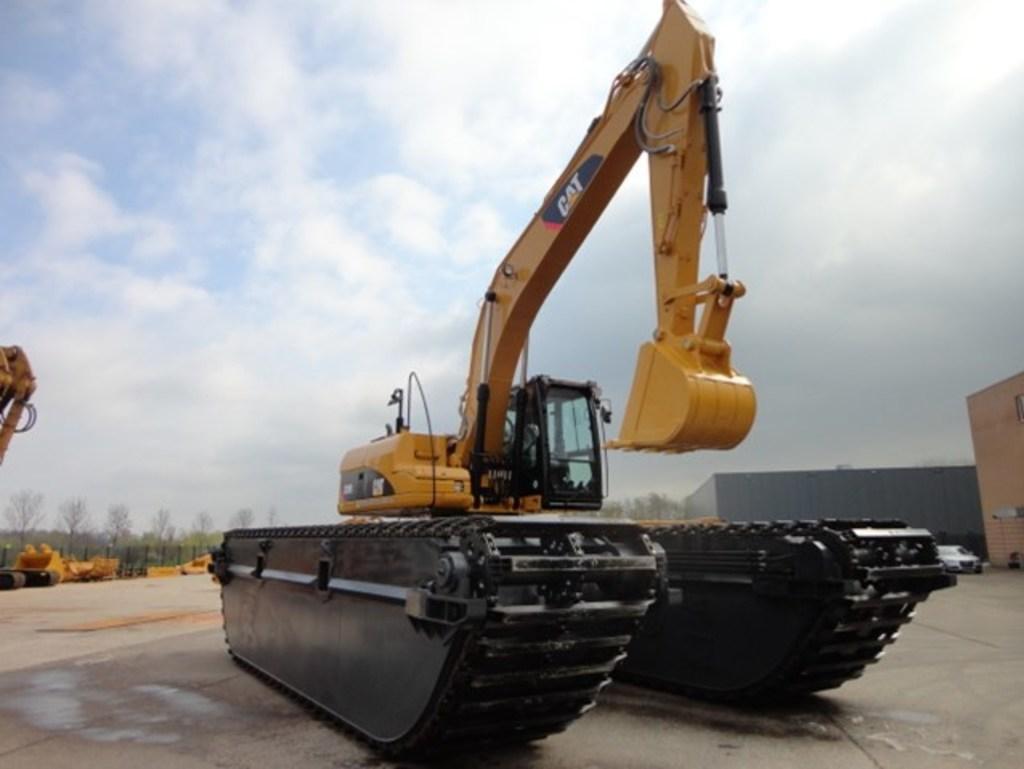Describe this image in one or two sentences. In this picture we can see a crane in the front, on the right side there are buildings and a car, we can see another crane on the left side, in the background we can see trees, we can see the sky at the top of the picture. 